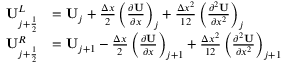<formula> <loc_0><loc_0><loc_500><loc_500>\begin{array} { r l } { U _ { j + \frac { 1 } { 2 } } ^ { L } } & { = { U } _ { j } + \frac { \Delta x } { 2 } \left ( \frac { \partial U } { \partial x } \right ) _ { j } + \frac { \Delta x ^ { 2 } } { 1 2 } \left ( \frac { \partial ^ { 2 } U } { \partial x ^ { 2 } } \right ) _ { j } } \\ { U _ { j + \frac { 1 } { 2 } } ^ { R } } & { = { U } _ { j + 1 } - \frac { \Delta x } { 2 } \left ( \frac { \partial U } { \partial x } \right ) _ { j + 1 } + \frac { \Delta x ^ { 2 } } { 1 2 } \left ( \frac { \partial ^ { 2 } U } { \partial x ^ { 2 } } \right ) _ { j + 1 } \quad } \end{array}</formula> 